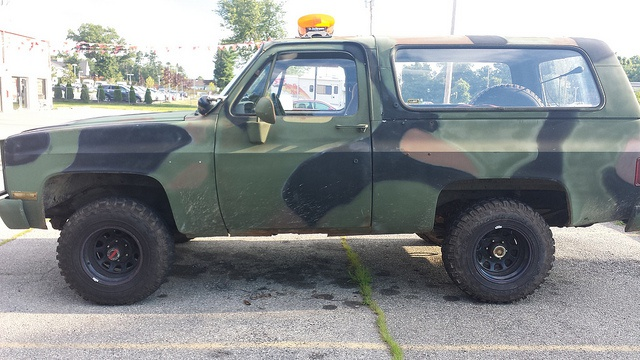Describe the objects in this image and their specific colors. I can see truck in white, gray, black, and darkgray tones, car in white, gray, and darkgray tones, car in white, darkgray, and lightgray tones, and people in darkgray, lightgray, khaki, white, and beige tones in this image. 